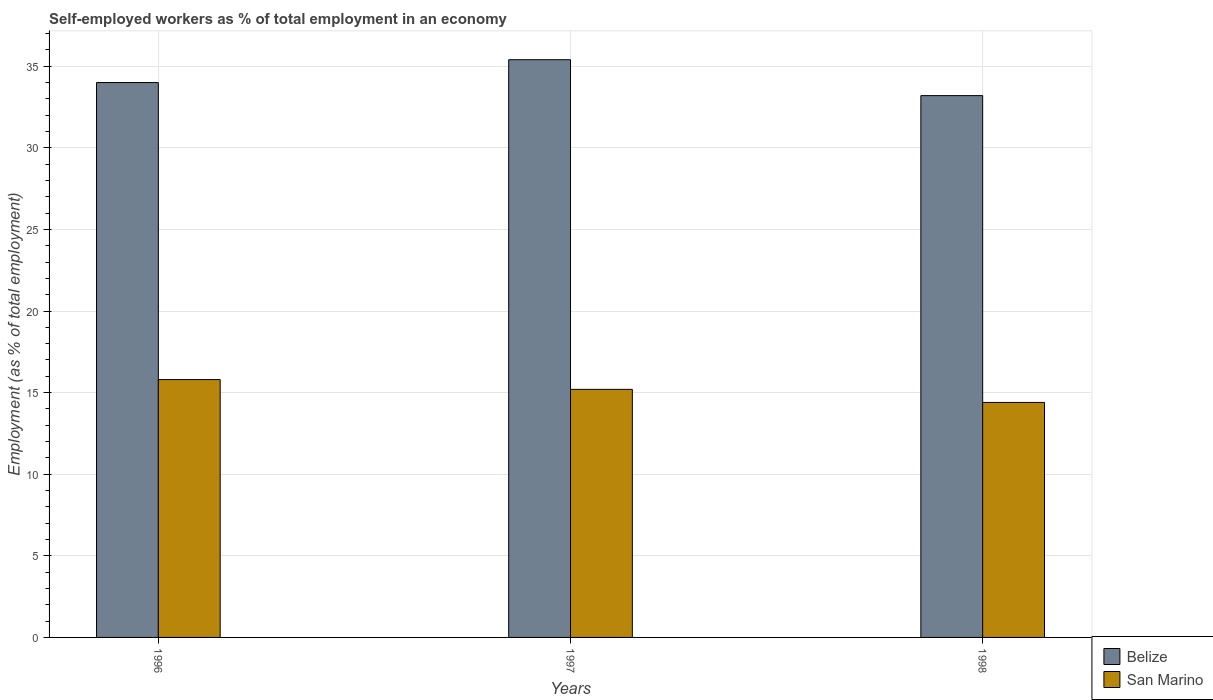Are the number of bars on each tick of the X-axis equal?
Provide a short and direct response. Yes. How many bars are there on the 2nd tick from the right?
Your response must be concise. 2. In how many cases, is the number of bars for a given year not equal to the number of legend labels?
Offer a very short reply. 0. What is the percentage of self-employed workers in San Marino in 1998?
Offer a terse response. 14.4. Across all years, what is the maximum percentage of self-employed workers in Belize?
Give a very brief answer. 35.4. Across all years, what is the minimum percentage of self-employed workers in San Marino?
Your answer should be compact. 14.4. In which year was the percentage of self-employed workers in Belize maximum?
Give a very brief answer. 1997. In which year was the percentage of self-employed workers in San Marino minimum?
Give a very brief answer. 1998. What is the total percentage of self-employed workers in San Marino in the graph?
Keep it short and to the point. 45.4. What is the difference between the percentage of self-employed workers in Belize in 1997 and that in 1998?
Provide a short and direct response. 2.2. What is the difference between the percentage of self-employed workers in San Marino in 1997 and the percentage of self-employed workers in Belize in 1996?
Ensure brevity in your answer.  -18.8. What is the average percentage of self-employed workers in San Marino per year?
Offer a very short reply. 15.13. In the year 1997, what is the difference between the percentage of self-employed workers in San Marino and percentage of self-employed workers in Belize?
Ensure brevity in your answer.  -20.2. In how many years, is the percentage of self-employed workers in Belize greater than 6 %?
Offer a terse response. 3. What is the ratio of the percentage of self-employed workers in San Marino in 1997 to that in 1998?
Keep it short and to the point. 1.06. Is the difference between the percentage of self-employed workers in San Marino in 1996 and 1997 greater than the difference between the percentage of self-employed workers in Belize in 1996 and 1997?
Offer a terse response. Yes. What is the difference between the highest and the second highest percentage of self-employed workers in Belize?
Offer a terse response. 1.4. What is the difference between the highest and the lowest percentage of self-employed workers in Belize?
Offer a terse response. 2.2. Is the sum of the percentage of self-employed workers in San Marino in 1996 and 1997 greater than the maximum percentage of self-employed workers in Belize across all years?
Offer a very short reply. No. What does the 2nd bar from the left in 1997 represents?
Your answer should be compact. San Marino. What does the 1st bar from the right in 1998 represents?
Give a very brief answer. San Marino. Are the values on the major ticks of Y-axis written in scientific E-notation?
Offer a very short reply. No. Does the graph contain grids?
Offer a terse response. Yes. Where does the legend appear in the graph?
Provide a succinct answer. Bottom right. What is the title of the graph?
Ensure brevity in your answer.  Self-employed workers as % of total employment in an economy. What is the label or title of the X-axis?
Your response must be concise. Years. What is the label or title of the Y-axis?
Provide a succinct answer. Employment (as % of total employment). What is the Employment (as % of total employment) of San Marino in 1996?
Your answer should be very brief. 15.8. What is the Employment (as % of total employment) in Belize in 1997?
Offer a terse response. 35.4. What is the Employment (as % of total employment) in San Marino in 1997?
Your answer should be compact. 15.2. What is the Employment (as % of total employment) in Belize in 1998?
Keep it short and to the point. 33.2. What is the Employment (as % of total employment) of San Marino in 1998?
Offer a very short reply. 14.4. Across all years, what is the maximum Employment (as % of total employment) of Belize?
Provide a succinct answer. 35.4. Across all years, what is the maximum Employment (as % of total employment) in San Marino?
Give a very brief answer. 15.8. Across all years, what is the minimum Employment (as % of total employment) in Belize?
Provide a succinct answer. 33.2. Across all years, what is the minimum Employment (as % of total employment) in San Marino?
Keep it short and to the point. 14.4. What is the total Employment (as % of total employment) in Belize in the graph?
Keep it short and to the point. 102.6. What is the total Employment (as % of total employment) of San Marino in the graph?
Provide a short and direct response. 45.4. What is the difference between the Employment (as % of total employment) in San Marino in 1996 and that in 1998?
Your answer should be very brief. 1.4. What is the difference between the Employment (as % of total employment) in San Marino in 1997 and that in 1998?
Your response must be concise. 0.8. What is the difference between the Employment (as % of total employment) of Belize in 1996 and the Employment (as % of total employment) of San Marino in 1998?
Ensure brevity in your answer.  19.6. What is the average Employment (as % of total employment) of Belize per year?
Give a very brief answer. 34.2. What is the average Employment (as % of total employment) in San Marino per year?
Offer a very short reply. 15.13. In the year 1997, what is the difference between the Employment (as % of total employment) in Belize and Employment (as % of total employment) in San Marino?
Make the answer very short. 20.2. What is the ratio of the Employment (as % of total employment) of Belize in 1996 to that in 1997?
Give a very brief answer. 0.96. What is the ratio of the Employment (as % of total employment) in San Marino in 1996 to that in 1997?
Provide a succinct answer. 1.04. What is the ratio of the Employment (as % of total employment) of Belize in 1996 to that in 1998?
Ensure brevity in your answer.  1.02. What is the ratio of the Employment (as % of total employment) of San Marino in 1996 to that in 1998?
Offer a terse response. 1.1. What is the ratio of the Employment (as % of total employment) of Belize in 1997 to that in 1998?
Provide a short and direct response. 1.07. What is the ratio of the Employment (as % of total employment) of San Marino in 1997 to that in 1998?
Your answer should be very brief. 1.06. What is the difference between the highest and the lowest Employment (as % of total employment) in San Marino?
Your answer should be compact. 1.4. 